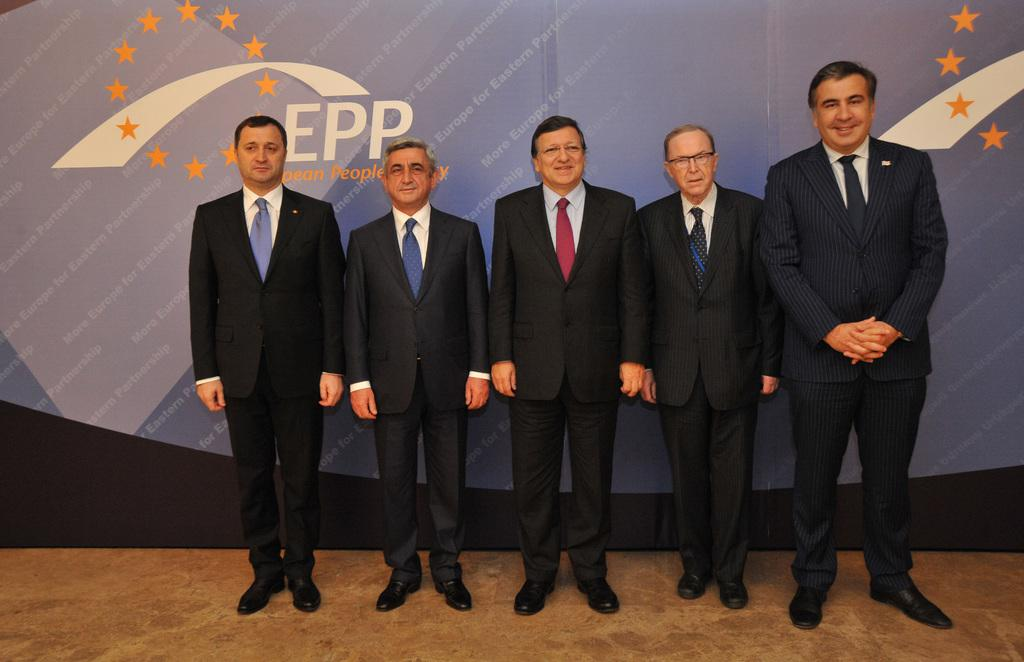How many men are present in the image? There are five men in the image. What are the men doing in the image? The men are standing on the floor. What are the men wearing in the image? The men are wearing suits. What can be seen hanging in the background of the image? There is a banner in the image. What color is the banner in the image? The banner is blue in color. What type of coil is being used by the men in the image? There is no coil present in the image. What kind of machine is being operated by the men in the image? There is no machine present in the image; the men are simply standing on the floor. 